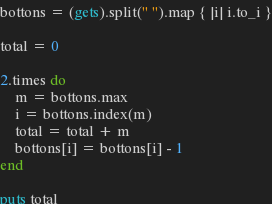<code> <loc_0><loc_0><loc_500><loc_500><_Ruby_>bottons = (gets).split(" ").map { |i| i.to_i }

total = 0

2.times do
    m = bottons.max
    i = bottons.index(m)
    total = total + m
    bottons[i] = bottons[i] - 1
end

puts total</code> 